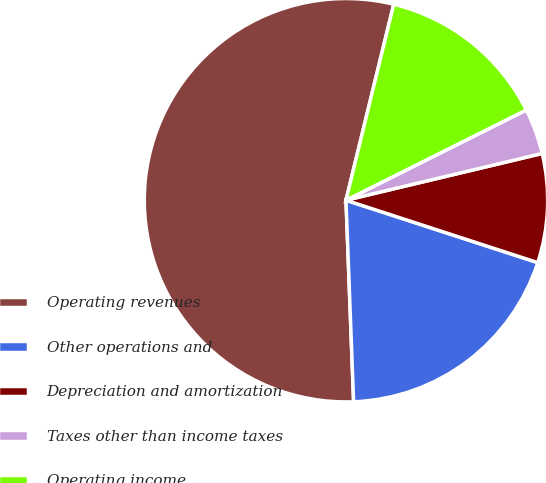Convert chart. <chart><loc_0><loc_0><loc_500><loc_500><pie_chart><fcel>Operating revenues<fcel>Other operations and<fcel>Depreciation and amortization<fcel>Taxes other than income taxes<fcel>Operating income<nl><fcel>54.4%<fcel>19.39%<fcel>8.73%<fcel>3.66%<fcel>13.81%<nl></chart> 